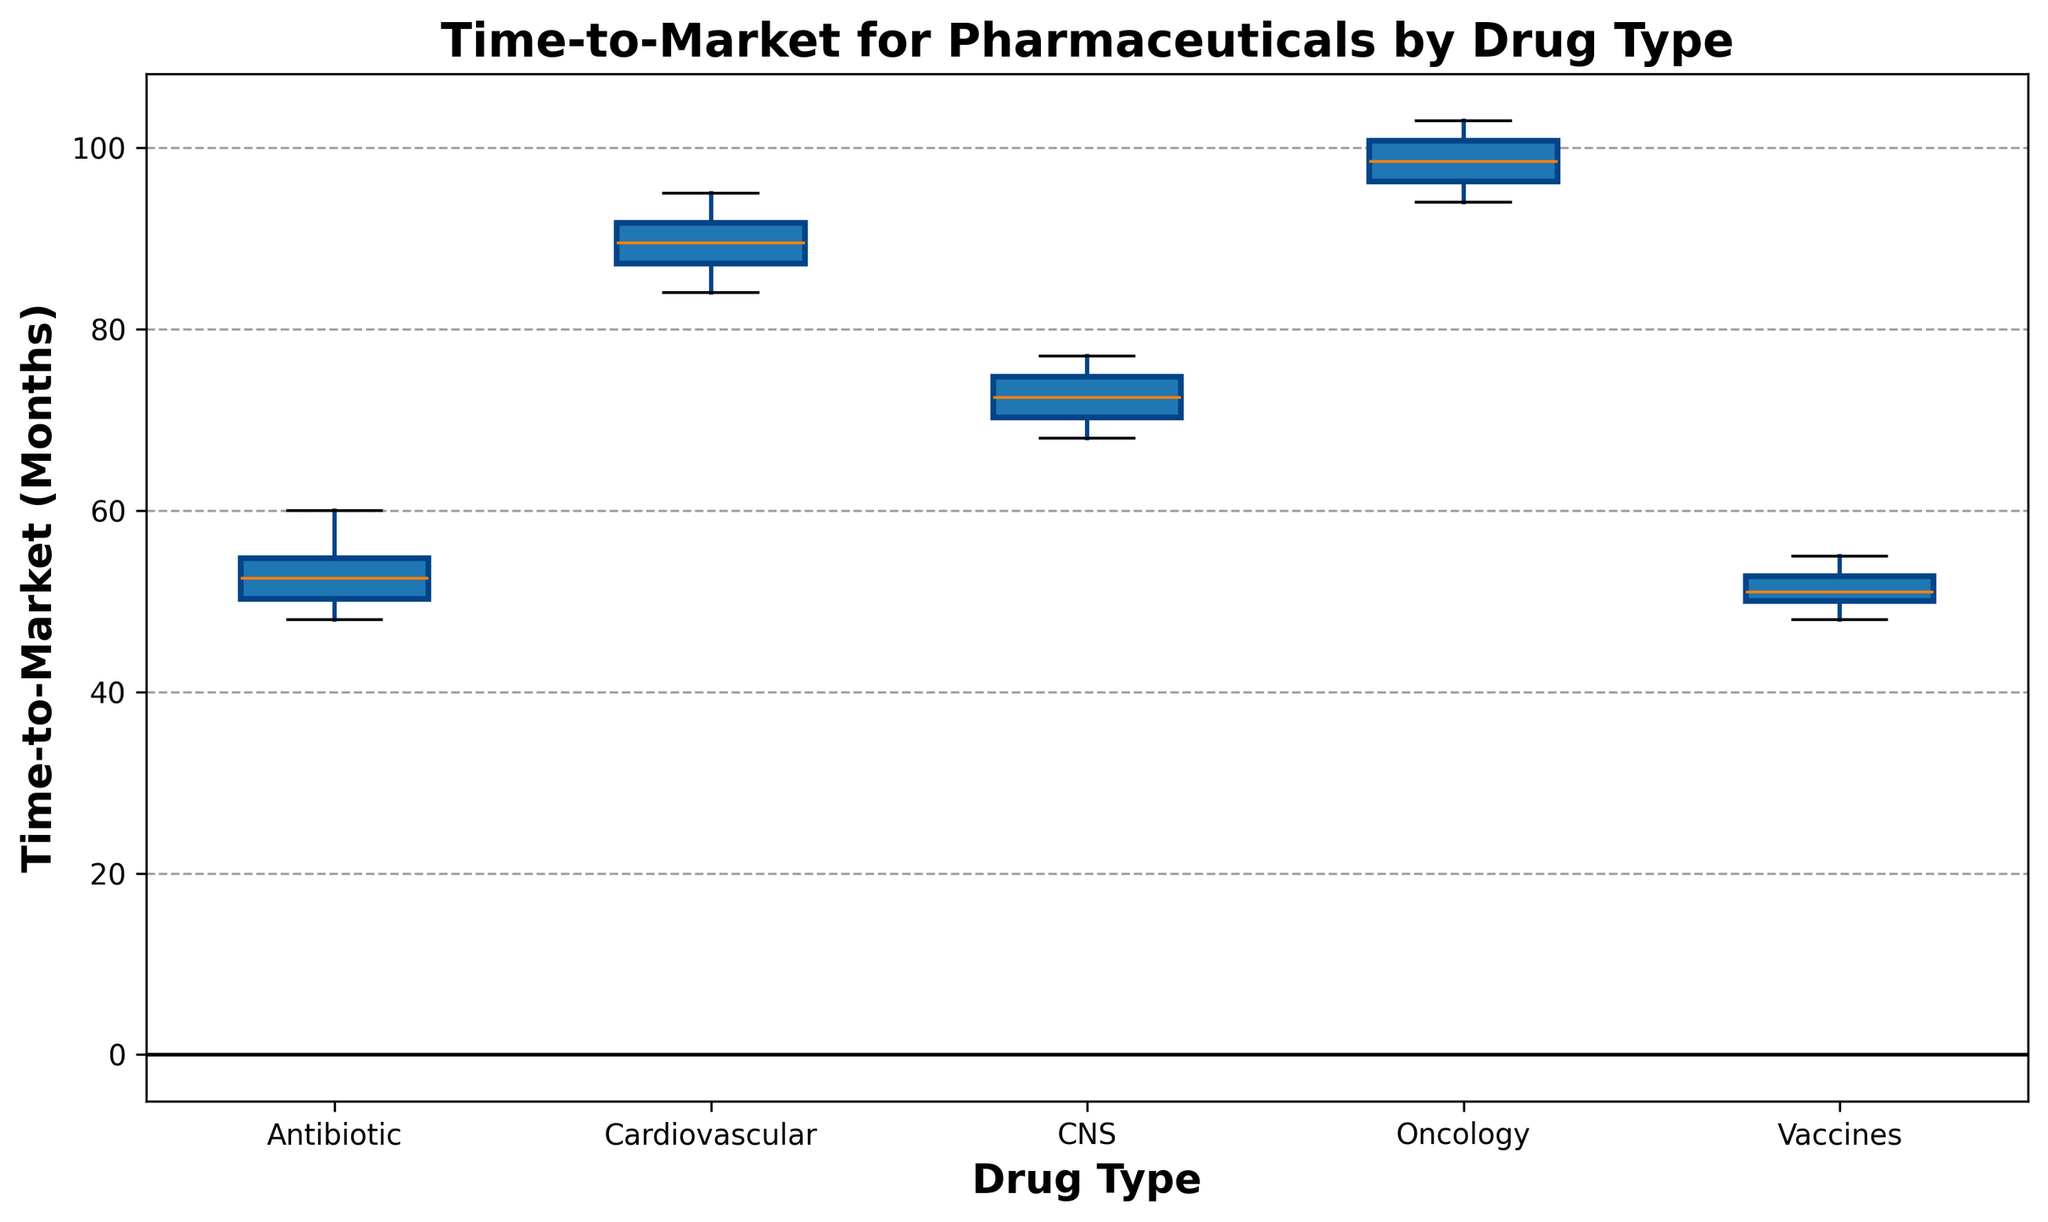How many drug types are compared in the box plot? The box plot shows different groups of drug types on the x-axis. By counting the number of distinct labels, we can determine the number of drug types compared. The labels are: Antibiotic, Cardiovascular, CNS, Oncology, Vaccines.
Answer: 5 Which drug type has the longest median time-to-market? The median time-to-market for each drug type is represented by the line inside the box of each box plot. By visually inspecting the position of these lines, we can identify that the Oncology drug type has the highest median time-to-market.
Answer: Oncology Which drug type has the largest interquartile range (IQR)? The interquartile range (IQR) is the range between the first quartile (Q1, the bottom of the box) and the third quartile (Q3, the top of the box). By visually comparing the height of the boxes, we see that the Cardiovascular drug type has the largest IQR.
Answer: Cardiovascular What is the approximate range of time-to-market for Vaccines? The range of time-to-market can be observed from the bottom whisker to the top whisker of the box plot for Vaccines. This approximately starts from 48 months to around 55 months.
Answer: 48 to 55 months Which drug type shows outliers and what are the outlier values? Outliers in a box plot are represented by points outside the whiskers. By looking for these points in each drug type's box plot, we can see that both CNS and Oncology show outliers. The outlier values for CNS are approximately 68 months, and for Oncology, there are no clear outliers visible.
Answer: CNS: 68 months, Oncology: none visible Comparing Antibiotic and CNS, which drug type has a wider range, and what is the difference? To find the range, subtract the minimum value from the maximum value for both Antibiotic and CNS. Antibiotic's range is 60-48=12 months and CNS's range is 77-68=9 months. Antibiotic has a wider range, and the difference is 12-9=3 months.
Answer: Antibiotic by 3 months How does the median time-to-market for Vaccines compare to that for Antibiotics? The median is represented by the line inside the box of each box plot. By comparing the line positions for Vaccines and Antibiotics, we can see that the median time-to-market for both is about the same at around 51 months.
Answer: Equal Rank the drug types from shortest to longest median time-to-market. The median time-to-market is represented by the central line in each box plot. By comparing the position of these lines, the ranking from shortest to longest is: Antibiotic (~51 months), Vaccines (~51 months), CNS (~72 months), Cardiovascular (~90 months), Oncology (~99 months).
Answer: Antibiotic, Vaccines, CNS, Cardiovascular, Oncology What's the average median time-to-market for all drug types? To calculate the average median time-to-market, first determine the median for each drug type: Antibiotic (51 months), Vaccines (51 months), CNS (72 months), Cardiovascular (90 months), Oncology (99 months). Sum these values and divide by the number of drug types (5). The calculation is (51 + 51 + 72 + 90 + 99) / 5 = 363 / 5 = 72.6 months.
Answer: 72.6 months 